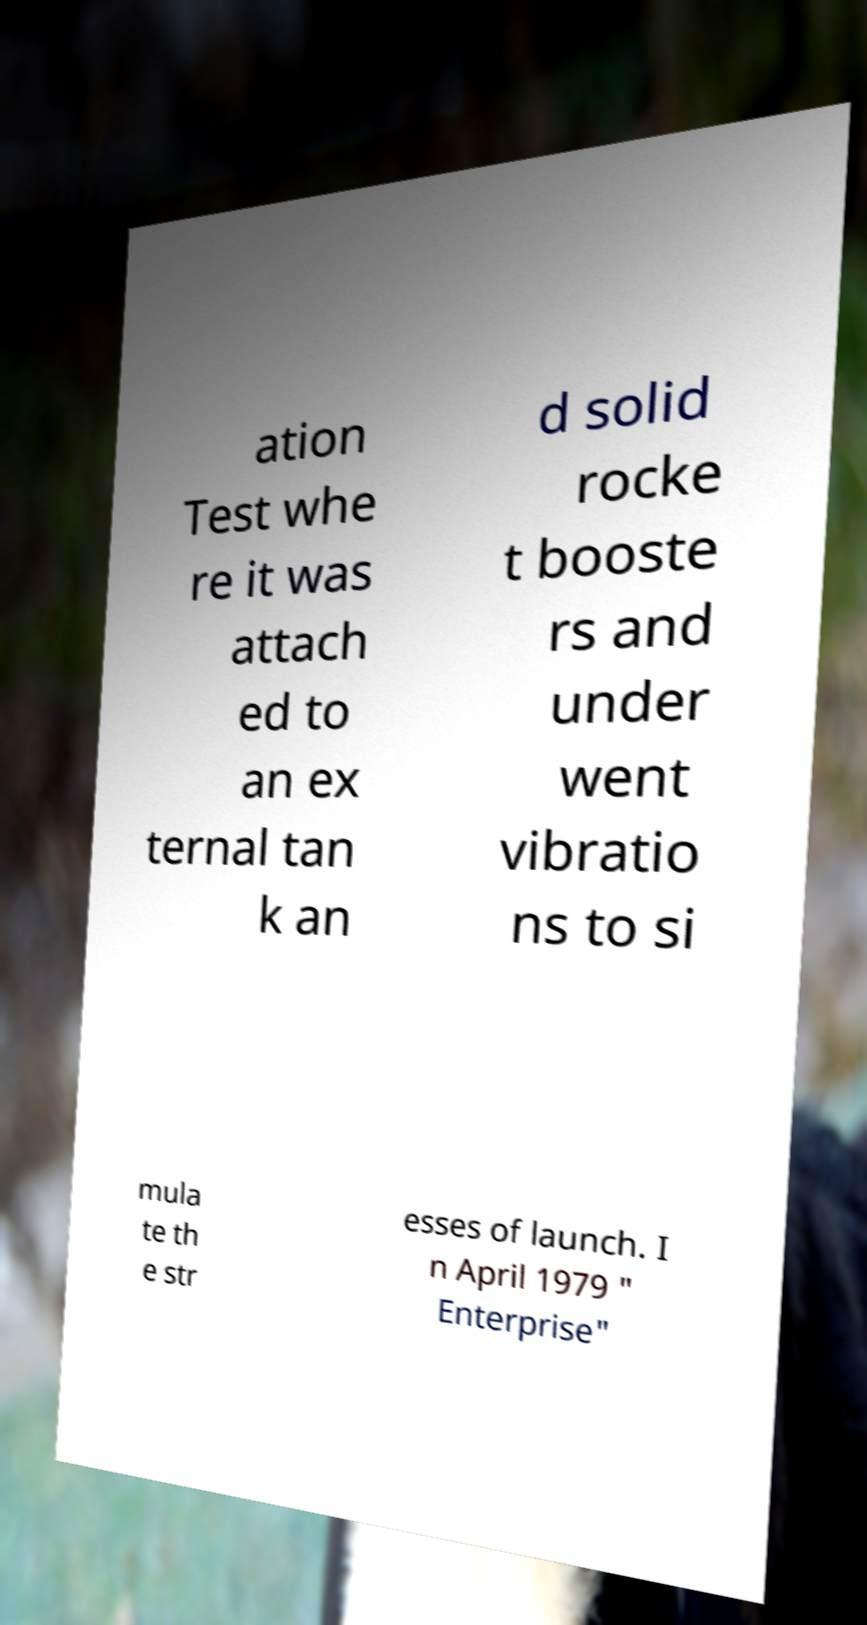Please read and relay the text visible in this image. What does it say? ation Test whe re it was attach ed to an ex ternal tan k an d solid rocke t booste rs and under went vibratio ns to si mula te th e str esses of launch. I n April 1979 " Enterprise" 